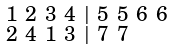<formula> <loc_0><loc_0><loc_500><loc_500>\begin{smallmatrix} 1 & 2 & 3 & 4 & | & 5 & 5 & 6 & 6 \\ 2 & 4 & 1 & 3 & | & 7 & 7 \end{smallmatrix}</formula> 